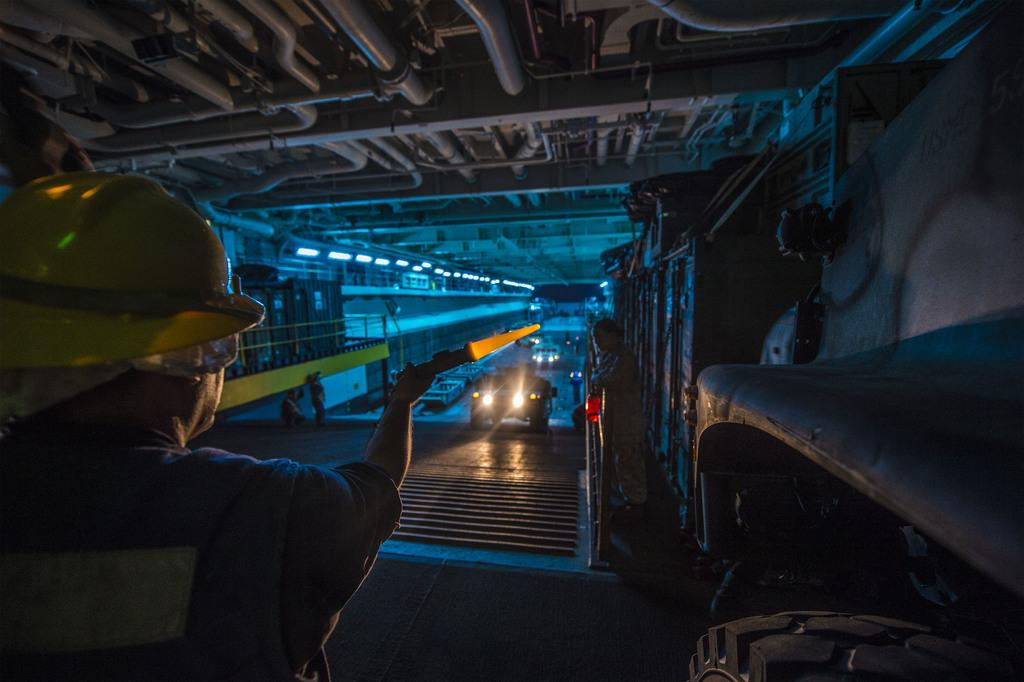Where was the image taken? The image was taken in a cellar. What can be seen in the center of the image? There are vehicles in the center of the image. What is visible at the top of the image? There are pipes visible at the top of the image. What type of destruction can be seen in the image? There is no destruction present in the image; it shows vehicles in a cellar with pipes visible at the top. 